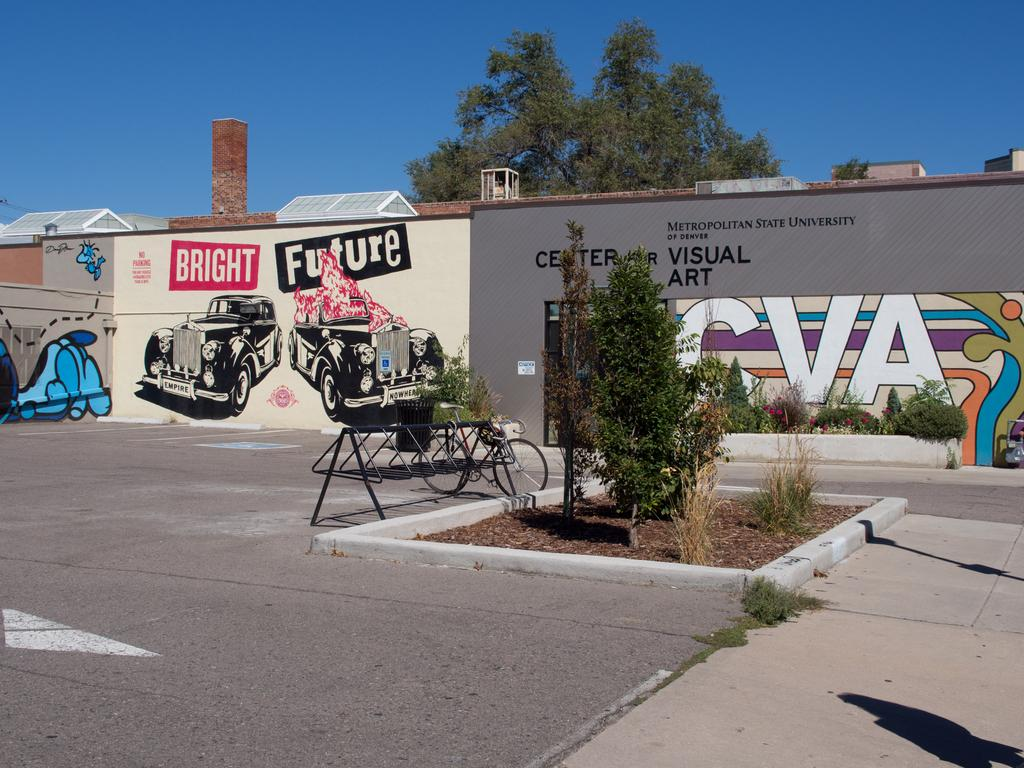What type of surface can be seen in the image? The ground is visible in the image. What type of vegetation is present in the image? There is grass in the image. What mode of transportation can be seen in the image? There is a bicycle in the image. What type of natural scenery is present in the image? There are trees in the image. What type of architectural feature is visible in the background of the image? There are walls in the background of the image. What type of artwork is present on the walls? There are paintings on the walls. What is the color of the sky in the image? The sky is blue in color. What is the taste of the bicycle in the image? There is no taste associated with the bicycle in the image, as bicycles are not edible objects. 